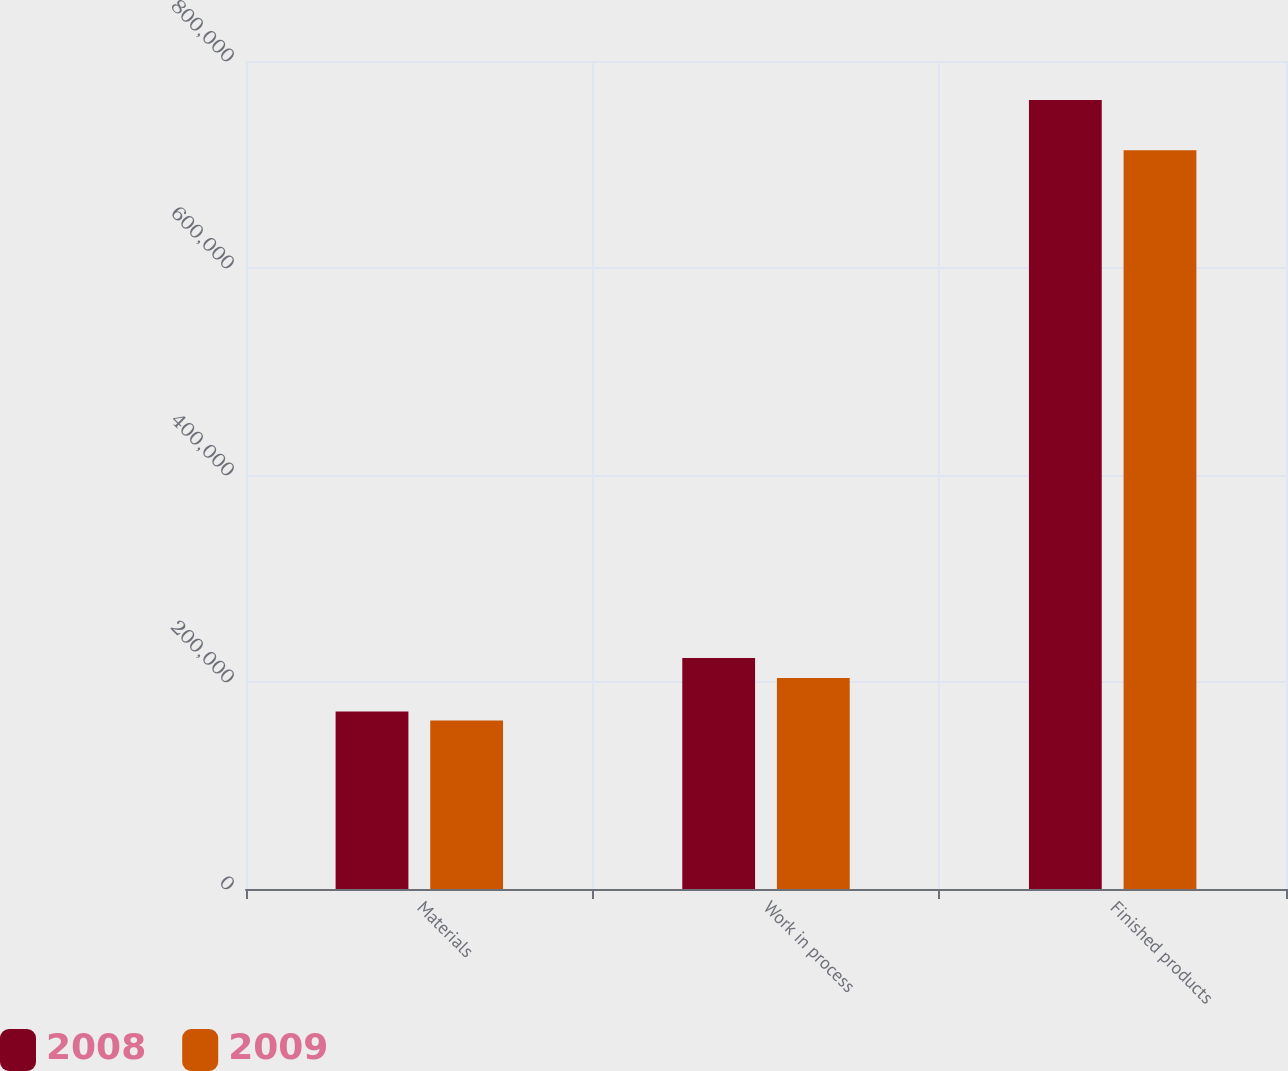Convert chart to OTSL. <chart><loc_0><loc_0><loc_500><loc_500><stacked_bar_chart><ecel><fcel>Materials<fcel>Work in process<fcel>Finished products<nl><fcel>2008<fcel>171449<fcel>223094<fcel>762219<nl><fcel>2009<fcel>162726<fcel>203926<fcel>713774<nl></chart> 